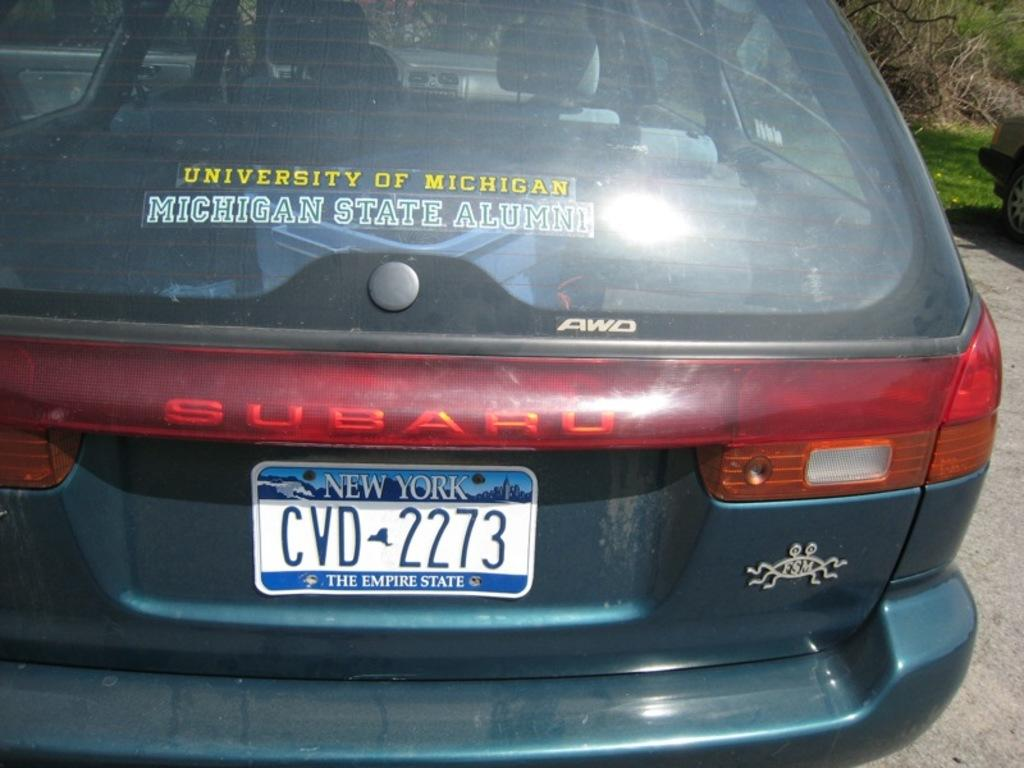<image>
Summarize the visual content of the image. A Subaru car with the license plate CVD 2273. 